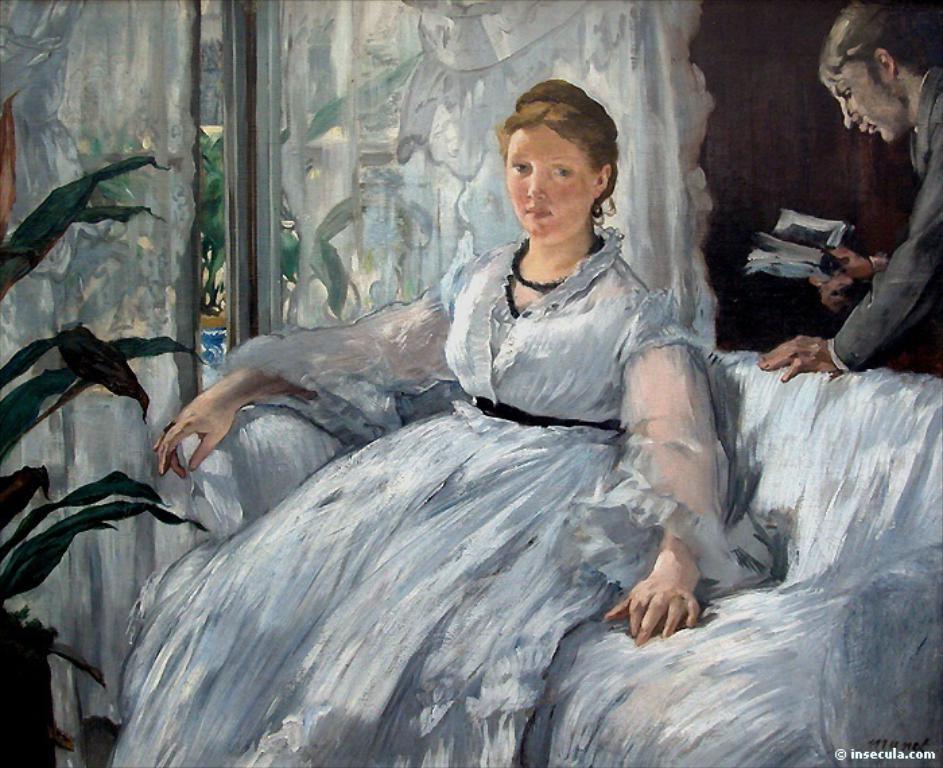Describe this image in one or two sentences. In this picture I can see there is a painting and there is a woman sitting on the couch and in the backdrop I can see there is a person standing and there is a plant on the left side. There is a window and there is a curtain. 